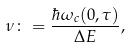<formula> <loc_0><loc_0><loc_500><loc_500>\nu \colon = \frac { \hbar { \omega } _ { c } ( 0 , \tau ) } { \Delta E } ,</formula> 